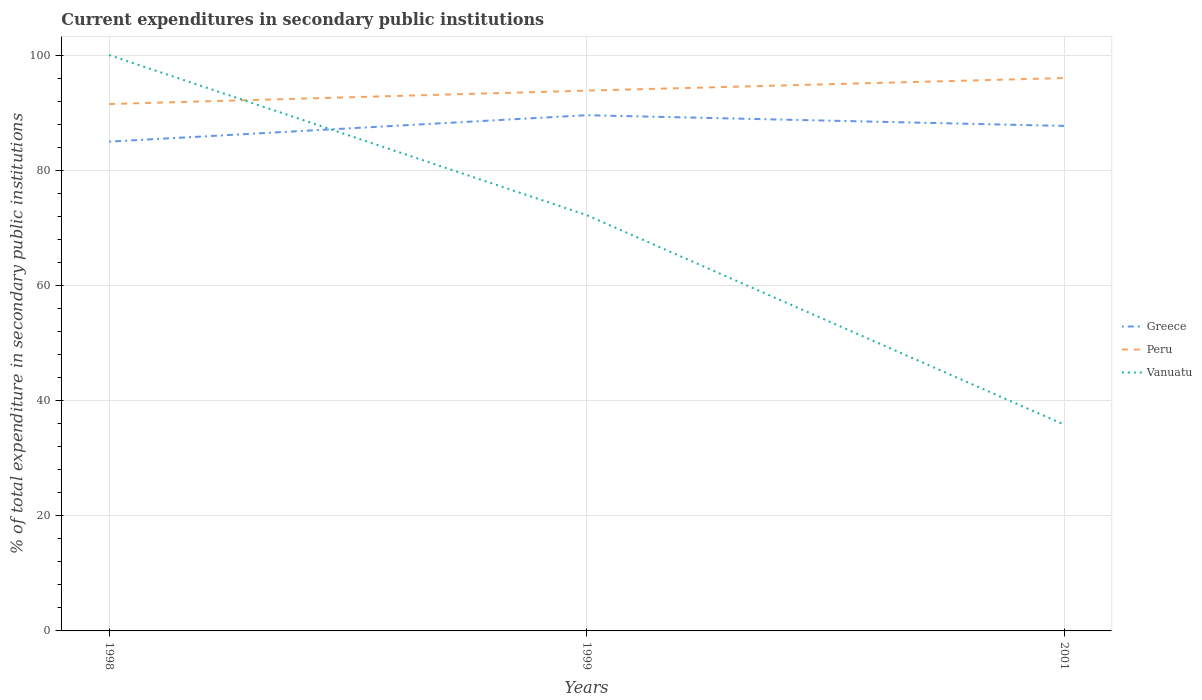How many different coloured lines are there?
Your response must be concise. 3. Does the line corresponding to Peru intersect with the line corresponding to Vanuatu?
Your response must be concise. Yes. Across all years, what is the maximum current expenditures in secondary public institutions in Vanuatu?
Ensure brevity in your answer.  35.83. What is the total current expenditures in secondary public institutions in Greece in the graph?
Your answer should be very brief. 1.86. What is the difference between the highest and the second highest current expenditures in secondary public institutions in Greece?
Keep it short and to the point. 4.59. What is the difference between the highest and the lowest current expenditures in secondary public institutions in Greece?
Your response must be concise. 2. Is the current expenditures in secondary public institutions in Peru strictly greater than the current expenditures in secondary public institutions in Vanuatu over the years?
Give a very brief answer. No. How many lines are there?
Ensure brevity in your answer.  3. What is the difference between two consecutive major ticks on the Y-axis?
Your answer should be very brief. 20. Where does the legend appear in the graph?
Make the answer very short. Center right. What is the title of the graph?
Your response must be concise. Current expenditures in secondary public institutions. Does "South Sudan" appear as one of the legend labels in the graph?
Ensure brevity in your answer.  No. What is the label or title of the X-axis?
Your response must be concise. Years. What is the label or title of the Y-axis?
Offer a very short reply. % of total expenditure in secondary public institutions. What is the % of total expenditure in secondary public institutions of Greece in 1998?
Your answer should be very brief. 84.97. What is the % of total expenditure in secondary public institutions in Peru in 1998?
Offer a terse response. 91.49. What is the % of total expenditure in secondary public institutions in Vanuatu in 1998?
Keep it short and to the point. 100. What is the % of total expenditure in secondary public institutions of Greece in 1999?
Your answer should be compact. 89.55. What is the % of total expenditure in secondary public institutions in Peru in 1999?
Your answer should be very brief. 93.82. What is the % of total expenditure in secondary public institutions in Vanuatu in 1999?
Keep it short and to the point. 72.21. What is the % of total expenditure in secondary public institutions in Greece in 2001?
Give a very brief answer. 87.69. What is the % of total expenditure in secondary public institutions in Peru in 2001?
Make the answer very short. 96.01. What is the % of total expenditure in secondary public institutions in Vanuatu in 2001?
Ensure brevity in your answer.  35.83. Across all years, what is the maximum % of total expenditure in secondary public institutions in Greece?
Your answer should be compact. 89.55. Across all years, what is the maximum % of total expenditure in secondary public institutions of Peru?
Provide a succinct answer. 96.01. Across all years, what is the maximum % of total expenditure in secondary public institutions of Vanuatu?
Offer a very short reply. 100. Across all years, what is the minimum % of total expenditure in secondary public institutions in Greece?
Give a very brief answer. 84.97. Across all years, what is the minimum % of total expenditure in secondary public institutions of Peru?
Provide a succinct answer. 91.49. Across all years, what is the minimum % of total expenditure in secondary public institutions in Vanuatu?
Make the answer very short. 35.83. What is the total % of total expenditure in secondary public institutions in Greece in the graph?
Give a very brief answer. 262.21. What is the total % of total expenditure in secondary public institutions in Peru in the graph?
Offer a very short reply. 281.33. What is the total % of total expenditure in secondary public institutions of Vanuatu in the graph?
Your answer should be very brief. 208.04. What is the difference between the % of total expenditure in secondary public institutions of Greece in 1998 and that in 1999?
Your answer should be compact. -4.59. What is the difference between the % of total expenditure in secondary public institutions of Peru in 1998 and that in 1999?
Offer a terse response. -2.33. What is the difference between the % of total expenditure in secondary public institutions in Vanuatu in 1998 and that in 1999?
Provide a succinct answer. 27.79. What is the difference between the % of total expenditure in secondary public institutions of Greece in 1998 and that in 2001?
Provide a short and direct response. -2.73. What is the difference between the % of total expenditure in secondary public institutions of Peru in 1998 and that in 2001?
Keep it short and to the point. -4.51. What is the difference between the % of total expenditure in secondary public institutions in Vanuatu in 1998 and that in 2001?
Your response must be concise. 64.17. What is the difference between the % of total expenditure in secondary public institutions in Greece in 1999 and that in 2001?
Make the answer very short. 1.86. What is the difference between the % of total expenditure in secondary public institutions of Peru in 1999 and that in 2001?
Give a very brief answer. -2.19. What is the difference between the % of total expenditure in secondary public institutions in Vanuatu in 1999 and that in 2001?
Offer a very short reply. 36.37. What is the difference between the % of total expenditure in secondary public institutions in Greece in 1998 and the % of total expenditure in secondary public institutions in Peru in 1999?
Your answer should be very brief. -8.86. What is the difference between the % of total expenditure in secondary public institutions in Greece in 1998 and the % of total expenditure in secondary public institutions in Vanuatu in 1999?
Keep it short and to the point. 12.76. What is the difference between the % of total expenditure in secondary public institutions in Peru in 1998 and the % of total expenditure in secondary public institutions in Vanuatu in 1999?
Your answer should be compact. 19.29. What is the difference between the % of total expenditure in secondary public institutions in Greece in 1998 and the % of total expenditure in secondary public institutions in Peru in 2001?
Give a very brief answer. -11.04. What is the difference between the % of total expenditure in secondary public institutions in Greece in 1998 and the % of total expenditure in secondary public institutions in Vanuatu in 2001?
Offer a very short reply. 49.13. What is the difference between the % of total expenditure in secondary public institutions of Peru in 1998 and the % of total expenditure in secondary public institutions of Vanuatu in 2001?
Keep it short and to the point. 55.66. What is the difference between the % of total expenditure in secondary public institutions in Greece in 1999 and the % of total expenditure in secondary public institutions in Peru in 2001?
Make the answer very short. -6.46. What is the difference between the % of total expenditure in secondary public institutions of Greece in 1999 and the % of total expenditure in secondary public institutions of Vanuatu in 2001?
Offer a very short reply. 53.72. What is the difference between the % of total expenditure in secondary public institutions of Peru in 1999 and the % of total expenditure in secondary public institutions of Vanuatu in 2001?
Provide a succinct answer. 57.99. What is the average % of total expenditure in secondary public institutions in Greece per year?
Keep it short and to the point. 87.4. What is the average % of total expenditure in secondary public institutions of Peru per year?
Give a very brief answer. 93.78. What is the average % of total expenditure in secondary public institutions of Vanuatu per year?
Offer a terse response. 69.35. In the year 1998, what is the difference between the % of total expenditure in secondary public institutions of Greece and % of total expenditure in secondary public institutions of Peru?
Offer a terse response. -6.53. In the year 1998, what is the difference between the % of total expenditure in secondary public institutions of Greece and % of total expenditure in secondary public institutions of Vanuatu?
Your answer should be compact. -15.03. In the year 1998, what is the difference between the % of total expenditure in secondary public institutions of Peru and % of total expenditure in secondary public institutions of Vanuatu?
Offer a terse response. -8.51. In the year 1999, what is the difference between the % of total expenditure in secondary public institutions of Greece and % of total expenditure in secondary public institutions of Peru?
Give a very brief answer. -4.27. In the year 1999, what is the difference between the % of total expenditure in secondary public institutions of Greece and % of total expenditure in secondary public institutions of Vanuatu?
Your answer should be compact. 17.35. In the year 1999, what is the difference between the % of total expenditure in secondary public institutions in Peru and % of total expenditure in secondary public institutions in Vanuatu?
Your answer should be very brief. 21.62. In the year 2001, what is the difference between the % of total expenditure in secondary public institutions in Greece and % of total expenditure in secondary public institutions in Peru?
Your response must be concise. -8.32. In the year 2001, what is the difference between the % of total expenditure in secondary public institutions of Greece and % of total expenditure in secondary public institutions of Vanuatu?
Keep it short and to the point. 51.86. In the year 2001, what is the difference between the % of total expenditure in secondary public institutions of Peru and % of total expenditure in secondary public institutions of Vanuatu?
Make the answer very short. 60.18. What is the ratio of the % of total expenditure in secondary public institutions in Greece in 1998 to that in 1999?
Offer a very short reply. 0.95. What is the ratio of the % of total expenditure in secondary public institutions in Peru in 1998 to that in 1999?
Your response must be concise. 0.98. What is the ratio of the % of total expenditure in secondary public institutions in Vanuatu in 1998 to that in 1999?
Give a very brief answer. 1.38. What is the ratio of the % of total expenditure in secondary public institutions in Greece in 1998 to that in 2001?
Offer a terse response. 0.97. What is the ratio of the % of total expenditure in secondary public institutions in Peru in 1998 to that in 2001?
Your answer should be compact. 0.95. What is the ratio of the % of total expenditure in secondary public institutions of Vanuatu in 1998 to that in 2001?
Offer a terse response. 2.79. What is the ratio of the % of total expenditure in secondary public institutions of Greece in 1999 to that in 2001?
Your answer should be very brief. 1.02. What is the ratio of the % of total expenditure in secondary public institutions of Peru in 1999 to that in 2001?
Provide a succinct answer. 0.98. What is the ratio of the % of total expenditure in secondary public institutions of Vanuatu in 1999 to that in 2001?
Offer a very short reply. 2.02. What is the difference between the highest and the second highest % of total expenditure in secondary public institutions of Greece?
Offer a very short reply. 1.86. What is the difference between the highest and the second highest % of total expenditure in secondary public institutions in Peru?
Provide a short and direct response. 2.19. What is the difference between the highest and the second highest % of total expenditure in secondary public institutions of Vanuatu?
Provide a short and direct response. 27.79. What is the difference between the highest and the lowest % of total expenditure in secondary public institutions in Greece?
Your answer should be very brief. 4.59. What is the difference between the highest and the lowest % of total expenditure in secondary public institutions of Peru?
Provide a short and direct response. 4.51. What is the difference between the highest and the lowest % of total expenditure in secondary public institutions in Vanuatu?
Keep it short and to the point. 64.17. 